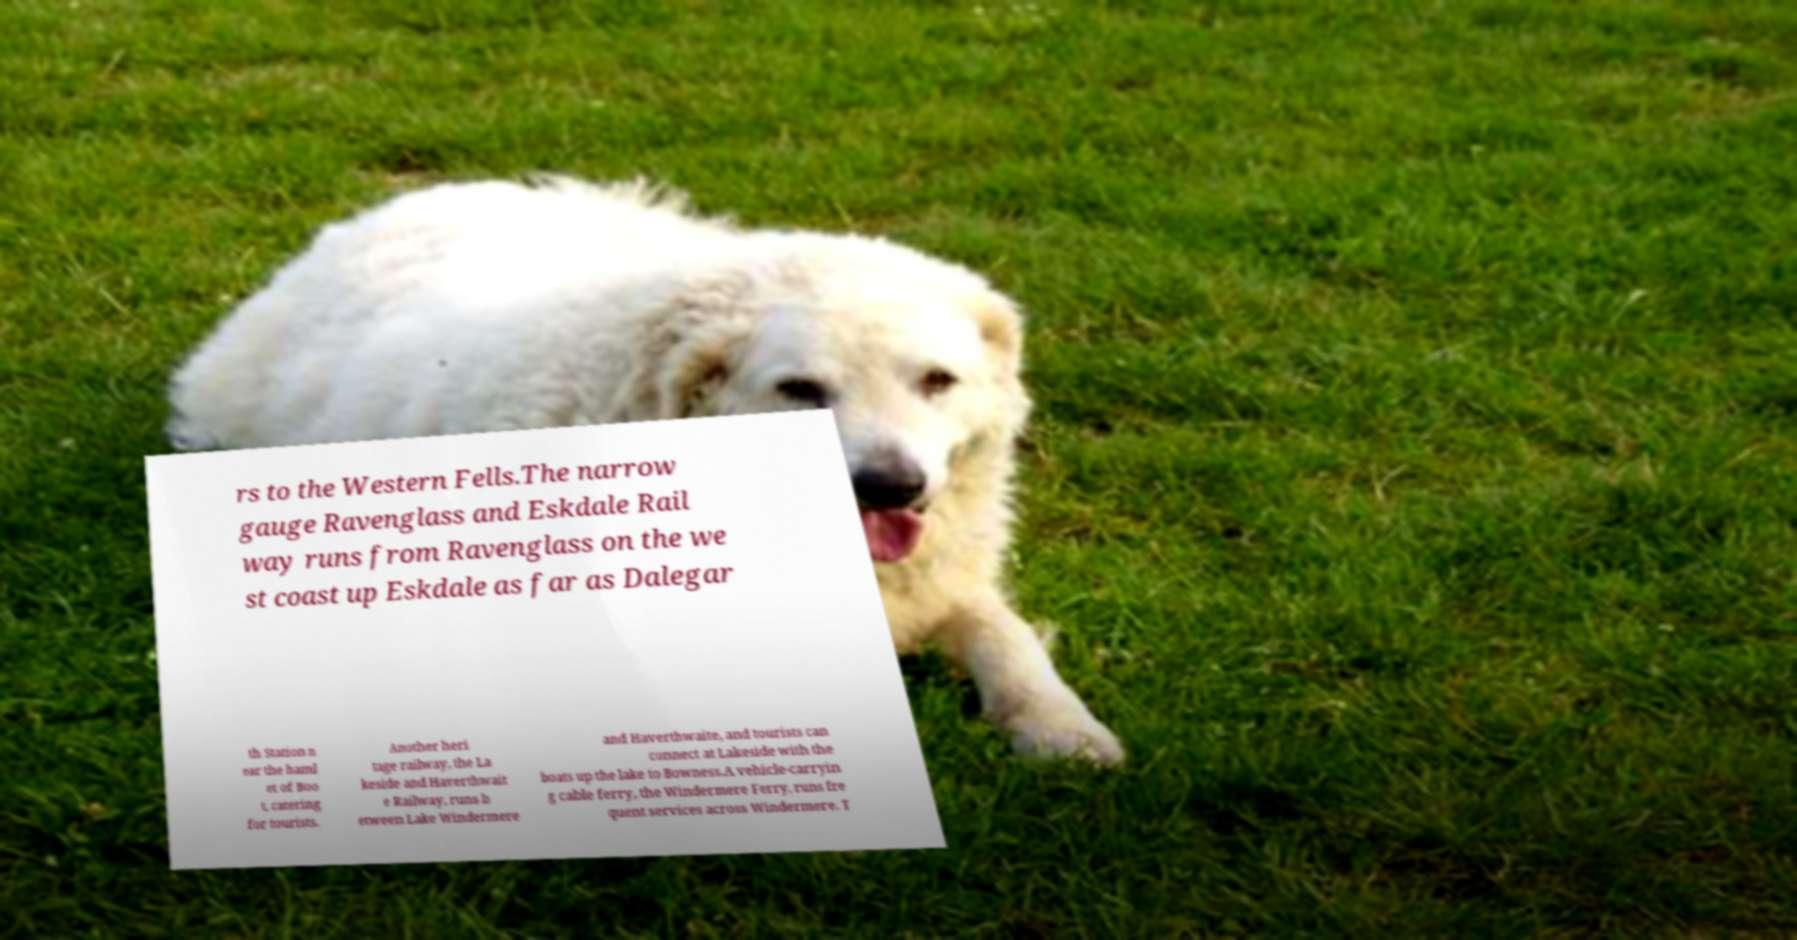There's text embedded in this image that I need extracted. Can you transcribe it verbatim? rs to the Western Fells.The narrow gauge Ravenglass and Eskdale Rail way runs from Ravenglass on the we st coast up Eskdale as far as Dalegar th Station n ear the haml et of Boo t, catering for tourists. Another heri tage railway, the La keside and Haverthwait e Railway, runs b etween Lake Windermere and Haverthwaite, and tourists can connect at Lakeside with the boats up the lake to Bowness.A vehicle-carryin g cable ferry, the Windermere Ferry, runs fre quent services across Windermere. T 